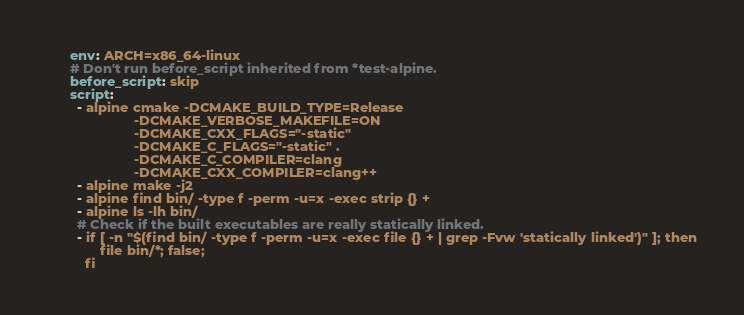Convert code to text. <code><loc_0><loc_0><loc_500><loc_500><_YAML_>      env: ARCH=x86_64-linux
      # Don't run before_script inherited from *test-alpine.
      before_script: skip
      script:
        - alpine cmake -DCMAKE_BUILD_TYPE=Release
                       -DCMAKE_VERBOSE_MAKEFILE=ON
                       -DCMAKE_CXX_FLAGS="-static"
                       -DCMAKE_C_FLAGS="-static" .
                       -DCMAKE_C_COMPILER=clang
                       -DCMAKE_CXX_COMPILER=clang++
        - alpine make -j2
        - alpine find bin/ -type f -perm -u=x -exec strip {} +
        - alpine ls -lh bin/
        # Check if the built executables are really statically linked.
        - if [ -n "$(find bin/ -type f -perm -u=x -exec file {} + | grep -Fvw 'statically linked')" ]; then
              file bin/*; false;
          fi</code> 